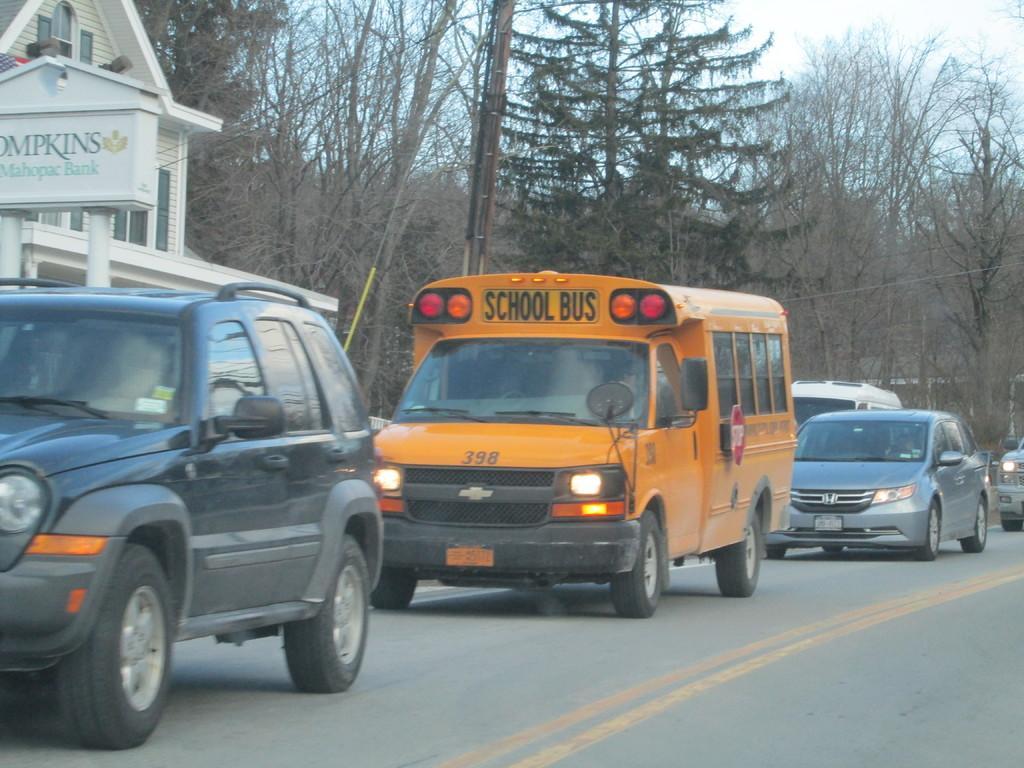Please provide a concise description of this image. In this picture, I can see there is a heavy traffic jam, They are three cars including one school bus and a van after that i can see a building next they are few trees which includes with dried trees and finally i can see a electrical pole and road. 